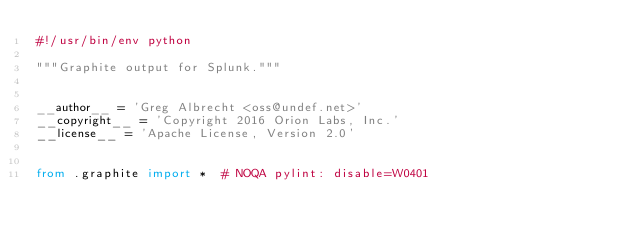<code> <loc_0><loc_0><loc_500><loc_500><_Python_>#!/usr/bin/env python

"""Graphite output for Splunk."""


__author__ = 'Greg Albrecht <oss@undef.net>'
__copyright__ = 'Copyright 2016 Orion Labs, Inc.'
__license__ = 'Apache License, Version 2.0'


from .graphite import *  # NOQA pylint: disable=W0401
</code> 